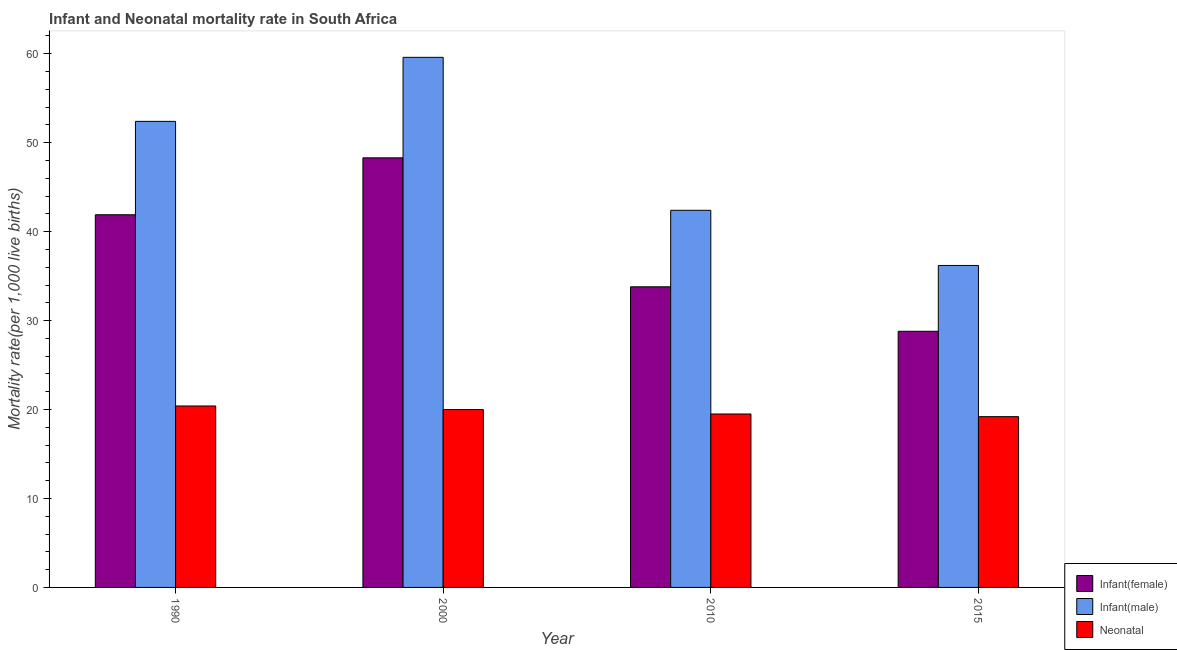How many different coloured bars are there?
Give a very brief answer. 3. Are the number of bars per tick equal to the number of legend labels?
Offer a very short reply. Yes. How many bars are there on the 1st tick from the right?
Your answer should be very brief. 3. What is the label of the 2nd group of bars from the left?
Offer a terse response. 2000. In how many cases, is the number of bars for a given year not equal to the number of legend labels?
Your answer should be very brief. 0. What is the infant mortality rate(female) in 1990?
Provide a succinct answer. 41.9. Across all years, what is the maximum neonatal mortality rate?
Your answer should be very brief. 20.4. Across all years, what is the minimum infant mortality rate(male)?
Your answer should be very brief. 36.2. In which year was the neonatal mortality rate maximum?
Provide a succinct answer. 1990. In which year was the infant mortality rate(female) minimum?
Make the answer very short. 2015. What is the total neonatal mortality rate in the graph?
Your answer should be very brief. 79.1. What is the difference between the infant mortality rate(male) in 1990 and that in 2000?
Offer a very short reply. -7.2. What is the difference between the infant mortality rate(male) in 2000 and the infant mortality rate(female) in 2015?
Make the answer very short. 23.4. What is the average infant mortality rate(female) per year?
Your response must be concise. 38.2. In the year 2000, what is the difference between the infant mortality rate(female) and infant mortality rate(male)?
Provide a short and direct response. 0. What is the ratio of the infant mortality rate(male) in 2000 to that in 2015?
Provide a short and direct response. 1.65. Is the neonatal mortality rate in 2010 less than that in 2015?
Your response must be concise. No. Is the difference between the infant mortality rate(female) in 2010 and 2015 greater than the difference between the neonatal mortality rate in 2010 and 2015?
Offer a very short reply. No. What is the difference between the highest and the second highest neonatal mortality rate?
Your response must be concise. 0.4. What is the difference between the highest and the lowest neonatal mortality rate?
Keep it short and to the point. 1.2. What does the 1st bar from the left in 2010 represents?
Provide a short and direct response. Infant(female). What does the 2nd bar from the right in 2015 represents?
Provide a short and direct response. Infant(male). How many years are there in the graph?
Offer a very short reply. 4. Where does the legend appear in the graph?
Your response must be concise. Bottom right. How many legend labels are there?
Ensure brevity in your answer.  3. How are the legend labels stacked?
Provide a succinct answer. Vertical. What is the title of the graph?
Give a very brief answer. Infant and Neonatal mortality rate in South Africa. What is the label or title of the X-axis?
Your response must be concise. Year. What is the label or title of the Y-axis?
Provide a short and direct response. Mortality rate(per 1,0 live births). What is the Mortality rate(per 1,000 live births) in Infant(female) in 1990?
Your answer should be very brief. 41.9. What is the Mortality rate(per 1,000 live births) in Infant(male) in 1990?
Your answer should be compact. 52.4. What is the Mortality rate(per 1,000 live births) of Neonatal  in 1990?
Your answer should be very brief. 20.4. What is the Mortality rate(per 1,000 live births) in Infant(female) in 2000?
Offer a terse response. 48.3. What is the Mortality rate(per 1,000 live births) of Infant(male) in 2000?
Ensure brevity in your answer.  59.6. What is the Mortality rate(per 1,000 live births) in Infant(female) in 2010?
Provide a succinct answer. 33.8. What is the Mortality rate(per 1,000 live births) of Infant(male) in 2010?
Your answer should be compact. 42.4. What is the Mortality rate(per 1,000 live births) in Infant(female) in 2015?
Keep it short and to the point. 28.8. What is the Mortality rate(per 1,000 live births) of Infant(male) in 2015?
Provide a short and direct response. 36.2. What is the Mortality rate(per 1,000 live births) in Neonatal  in 2015?
Offer a very short reply. 19.2. Across all years, what is the maximum Mortality rate(per 1,000 live births) of Infant(female)?
Offer a terse response. 48.3. Across all years, what is the maximum Mortality rate(per 1,000 live births) of Infant(male)?
Your response must be concise. 59.6. Across all years, what is the maximum Mortality rate(per 1,000 live births) in Neonatal ?
Give a very brief answer. 20.4. Across all years, what is the minimum Mortality rate(per 1,000 live births) in Infant(female)?
Offer a terse response. 28.8. Across all years, what is the minimum Mortality rate(per 1,000 live births) of Infant(male)?
Offer a terse response. 36.2. What is the total Mortality rate(per 1,000 live births) of Infant(female) in the graph?
Your answer should be very brief. 152.8. What is the total Mortality rate(per 1,000 live births) of Infant(male) in the graph?
Your response must be concise. 190.6. What is the total Mortality rate(per 1,000 live births) in Neonatal  in the graph?
Keep it short and to the point. 79.1. What is the difference between the Mortality rate(per 1,000 live births) of Infant(male) in 1990 and that in 2000?
Your answer should be very brief. -7.2. What is the difference between the Mortality rate(per 1,000 live births) of Neonatal  in 1990 and that in 2000?
Offer a terse response. 0.4. What is the difference between the Mortality rate(per 1,000 live births) of Infant(female) in 1990 and that in 2010?
Make the answer very short. 8.1. What is the difference between the Mortality rate(per 1,000 live births) of Neonatal  in 1990 and that in 2010?
Make the answer very short. 0.9. What is the difference between the Mortality rate(per 1,000 live births) of Infant(male) in 2000 and that in 2010?
Make the answer very short. 17.2. What is the difference between the Mortality rate(per 1,000 live births) in Neonatal  in 2000 and that in 2010?
Provide a short and direct response. 0.5. What is the difference between the Mortality rate(per 1,000 live births) of Infant(male) in 2000 and that in 2015?
Your response must be concise. 23.4. What is the difference between the Mortality rate(per 1,000 live births) of Infant(male) in 2010 and that in 2015?
Offer a very short reply. 6.2. What is the difference between the Mortality rate(per 1,000 live births) in Neonatal  in 2010 and that in 2015?
Your answer should be very brief. 0.3. What is the difference between the Mortality rate(per 1,000 live births) of Infant(female) in 1990 and the Mortality rate(per 1,000 live births) of Infant(male) in 2000?
Your answer should be compact. -17.7. What is the difference between the Mortality rate(per 1,000 live births) in Infant(female) in 1990 and the Mortality rate(per 1,000 live births) in Neonatal  in 2000?
Your answer should be compact. 21.9. What is the difference between the Mortality rate(per 1,000 live births) of Infant(male) in 1990 and the Mortality rate(per 1,000 live births) of Neonatal  in 2000?
Your response must be concise. 32.4. What is the difference between the Mortality rate(per 1,000 live births) of Infant(female) in 1990 and the Mortality rate(per 1,000 live births) of Neonatal  in 2010?
Your response must be concise. 22.4. What is the difference between the Mortality rate(per 1,000 live births) of Infant(male) in 1990 and the Mortality rate(per 1,000 live births) of Neonatal  in 2010?
Make the answer very short. 32.9. What is the difference between the Mortality rate(per 1,000 live births) in Infant(female) in 1990 and the Mortality rate(per 1,000 live births) in Neonatal  in 2015?
Your response must be concise. 22.7. What is the difference between the Mortality rate(per 1,000 live births) in Infant(male) in 1990 and the Mortality rate(per 1,000 live births) in Neonatal  in 2015?
Provide a short and direct response. 33.2. What is the difference between the Mortality rate(per 1,000 live births) of Infant(female) in 2000 and the Mortality rate(per 1,000 live births) of Infant(male) in 2010?
Offer a terse response. 5.9. What is the difference between the Mortality rate(per 1,000 live births) of Infant(female) in 2000 and the Mortality rate(per 1,000 live births) of Neonatal  in 2010?
Make the answer very short. 28.8. What is the difference between the Mortality rate(per 1,000 live births) in Infant(male) in 2000 and the Mortality rate(per 1,000 live births) in Neonatal  in 2010?
Provide a short and direct response. 40.1. What is the difference between the Mortality rate(per 1,000 live births) in Infant(female) in 2000 and the Mortality rate(per 1,000 live births) in Infant(male) in 2015?
Offer a very short reply. 12.1. What is the difference between the Mortality rate(per 1,000 live births) in Infant(female) in 2000 and the Mortality rate(per 1,000 live births) in Neonatal  in 2015?
Make the answer very short. 29.1. What is the difference between the Mortality rate(per 1,000 live births) of Infant(male) in 2000 and the Mortality rate(per 1,000 live births) of Neonatal  in 2015?
Your answer should be very brief. 40.4. What is the difference between the Mortality rate(per 1,000 live births) of Infant(female) in 2010 and the Mortality rate(per 1,000 live births) of Infant(male) in 2015?
Your answer should be very brief. -2.4. What is the difference between the Mortality rate(per 1,000 live births) in Infant(female) in 2010 and the Mortality rate(per 1,000 live births) in Neonatal  in 2015?
Your answer should be very brief. 14.6. What is the difference between the Mortality rate(per 1,000 live births) of Infant(male) in 2010 and the Mortality rate(per 1,000 live births) of Neonatal  in 2015?
Make the answer very short. 23.2. What is the average Mortality rate(per 1,000 live births) in Infant(female) per year?
Your answer should be compact. 38.2. What is the average Mortality rate(per 1,000 live births) of Infant(male) per year?
Your answer should be very brief. 47.65. What is the average Mortality rate(per 1,000 live births) of Neonatal  per year?
Ensure brevity in your answer.  19.77. In the year 1990, what is the difference between the Mortality rate(per 1,000 live births) of Infant(female) and Mortality rate(per 1,000 live births) of Infant(male)?
Provide a short and direct response. -10.5. In the year 1990, what is the difference between the Mortality rate(per 1,000 live births) of Infant(female) and Mortality rate(per 1,000 live births) of Neonatal ?
Provide a short and direct response. 21.5. In the year 1990, what is the difference between the Mortality rate(per 1,000 live births) of Infant(male) and Mortality rate(per 1,000 live births) of Neonatal ?
Keep it short and to the point. 32. In the year 2000, what is the difference between the Mortality rate(per 1,000 live births) of Infant(female) and Mortality rate(per 1,000 live births) of Infant(male)?
Your response must be concise. -11.3. In the year 2000, what is the difference between the Mortality rate(per 1,000 live births) in Infant(female) and Mortality rate(per 1,000 live births) in Neonatal ?
Ensure brevity in your answer.  28.3. In the year 2000, what is the difference between the Mortality rate(per 1,000 live births) in Infant(male) and Mortality rate(per 1,000 live births) in Neonatal ?
Offer a terse response. 39.6. In the year 2010, what is the difference between the Mortality rate(per 1,000 live births) of Infant(male) and Mortality rate(per 1,000 live births) of Neonatal ?
Ensure brevity in your answer.  22.9. In the year 2015, what is the difference between the Mortality rate(per 1,000 live births) of Infant(female) and Mortality rate(per 1,000 live births) of Neonatal ?
Your answer should be compact. 9.6. What is the ratio of the Mortality rate(per 1,000 live births) in Infant(female) in 1990 to that in 2000?
Give a very brief answer. 0.87. What is the ratio of the Mortality rate(per 1,000 live births) in Infant(male) in 1990 to that in 2000?
Your response must be concise. 0.88. What is the ratio of the Mortality rate(per 1,000 live births) in Infant(female) in 1990 to that in 2010?
Your answer should be compact. 1.24. What is the ratio of the Mortality rate(per 1,000 live births) of Infant(male) in 1990 to that in 2010?
Give a very brief answer. 1.24. What is the ratio of the Mortality rate(per 1,000 live births) in Neonatal  in 1990 to that in 2010?
Give a very brief answer. 1.05. What is the ratio of the Mortality rate(per 1,000 live births) of Infant(female) in 1990 to that in 2015?
Make the answer very short. 1.45. What is the ratio of the Mortality rate(per 1,000 live births) in Infant(male) in 1990 to that in 2015?
Give a very brief answer. 1.45. What is the ratio of the Mortality rate(per 1,000 live births) of Neonatal  in 1990 to that in 2015?
Provide a short and direct response. 1.06. What is the ratio of the Mortality rate(per 1,000 live births) of Infant(female) in 2000 to that in 2010?
Offer a terse response. 1.43. What is the ratio of the Mortality rate(per 1,000 live births) in Infant(male) in 2000 to that in 2010?
Ensure brevity in your answer.  1.41. What is the ratio of the Mortality rate(per 1,000 live births) in Neonatal  in 2000 to that in 2010?
Provide a succinct answer. 1.03. What is the ratio of the Mortality rate(per 1,000 live births) of Infant(female) in 2000 to that in 2015?
Your answer should be compact. 1.68. What is the ratio of the Mortality rate(per 1,000 live births) in Infant(male) in 2000 to that in 2015?
Give a very brief answer. 1.65. What is the ratio of the Mortality rate(per 1,000 live births) of Neonatal  in 2000 to that in 2015?
Make the answer very short. 1.04. What is the ratio of the Mortality rate(per 1,000 live births) in Infant(female) in 2010 to that in 2015?
Your response must be concise. 1.17. What is the ratio of the Mortality rate(per 1,000 live births) in Infant(male) in 2010 to that in 2015?
Give a very brief answer. 1.17. What is the ratio of the Mortality rate(per 1,000 live births) of Neonatal  in 2010 to that in 2015?
Provide a short and direct response. 1.02. What is the difference between the highest and the second highest Mortality rate(per 1,000 live births) in Infant(male)?
Your answer should be compact. 7.2. What is the difference between the highest and the second highest Mortality rate(per 1,000 live births) in Neonatal ?
Offer a terse response. 0.4. What is the difference between the highest and the lowest Mortality rate(per 1,000 live births) in Infant(female)?
Your response must be concise. 19.5. What is the difference between the highest and the lowest Mortality rate(per 1,000 live births) of Infant(male)?
Your answer should be compact. 23.4. 